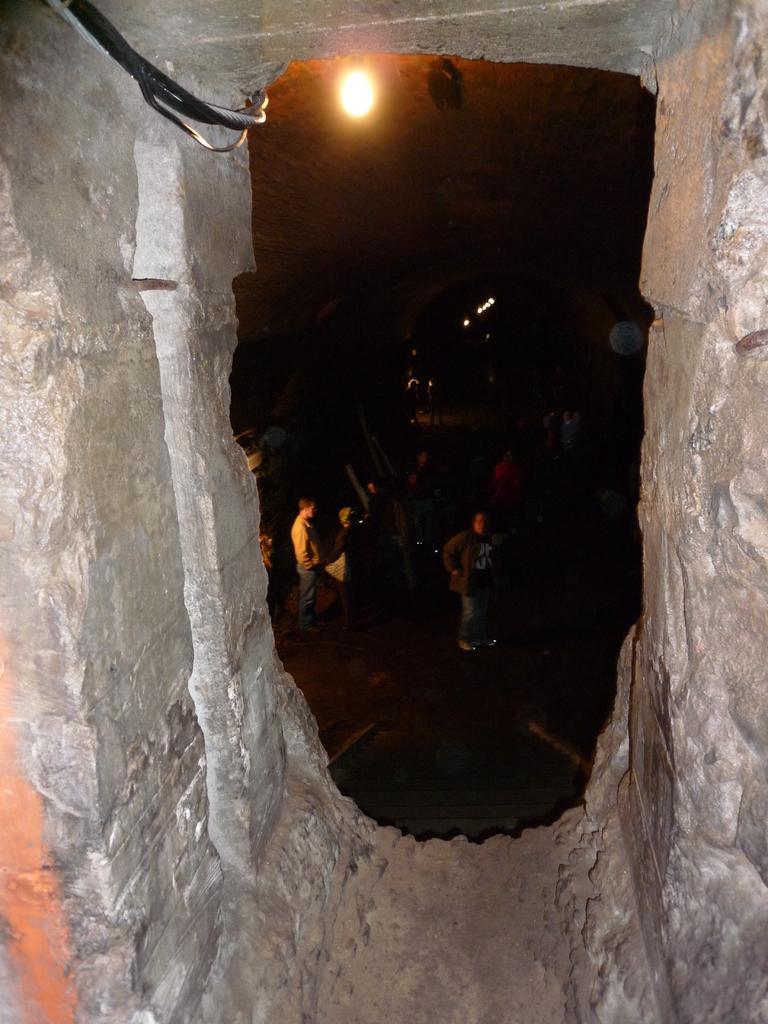Describe this image in one or two sentences. This picture consists of the wall , there is a hole on the wall and through hole I can see group of people on the road , there is a light , cable wire visible on the wall , this picture is might be taken during night. 